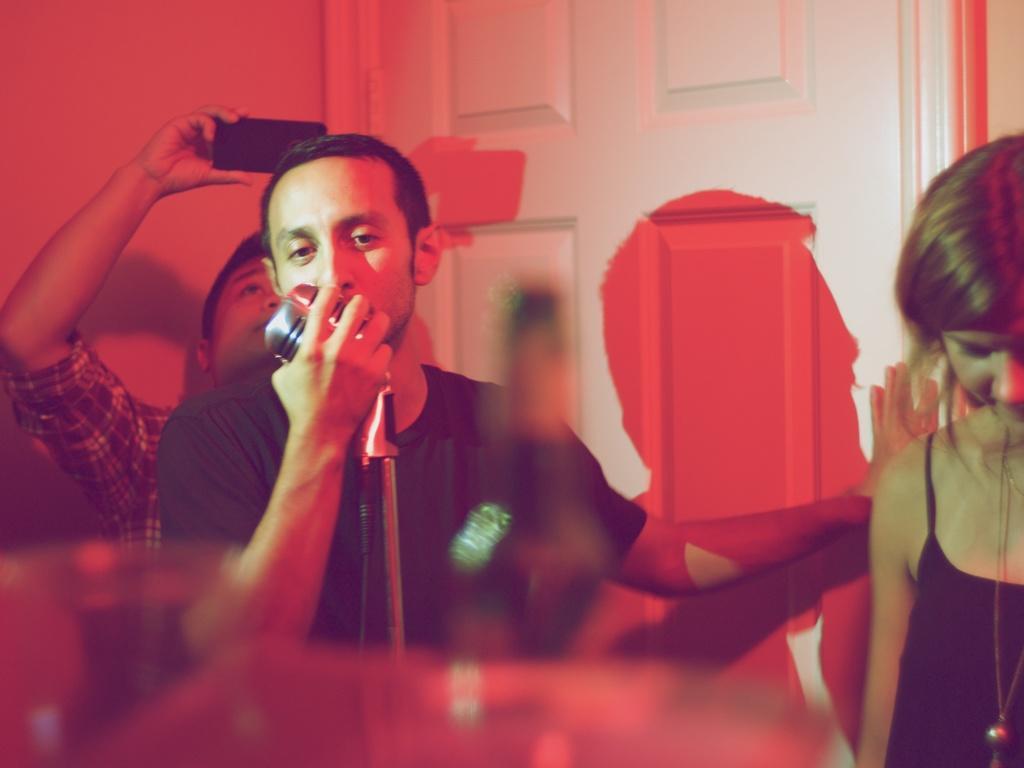Can you describe this image briefly? This picture is clicked inside. On the right there is a person. In the center there is a man wearing a black color t-shirt, holding a microphone and seems to be singing. In the background there is another person holding a mobile phone and we can see a wall and a white color door and we can see the shadows of the persons on the door. 